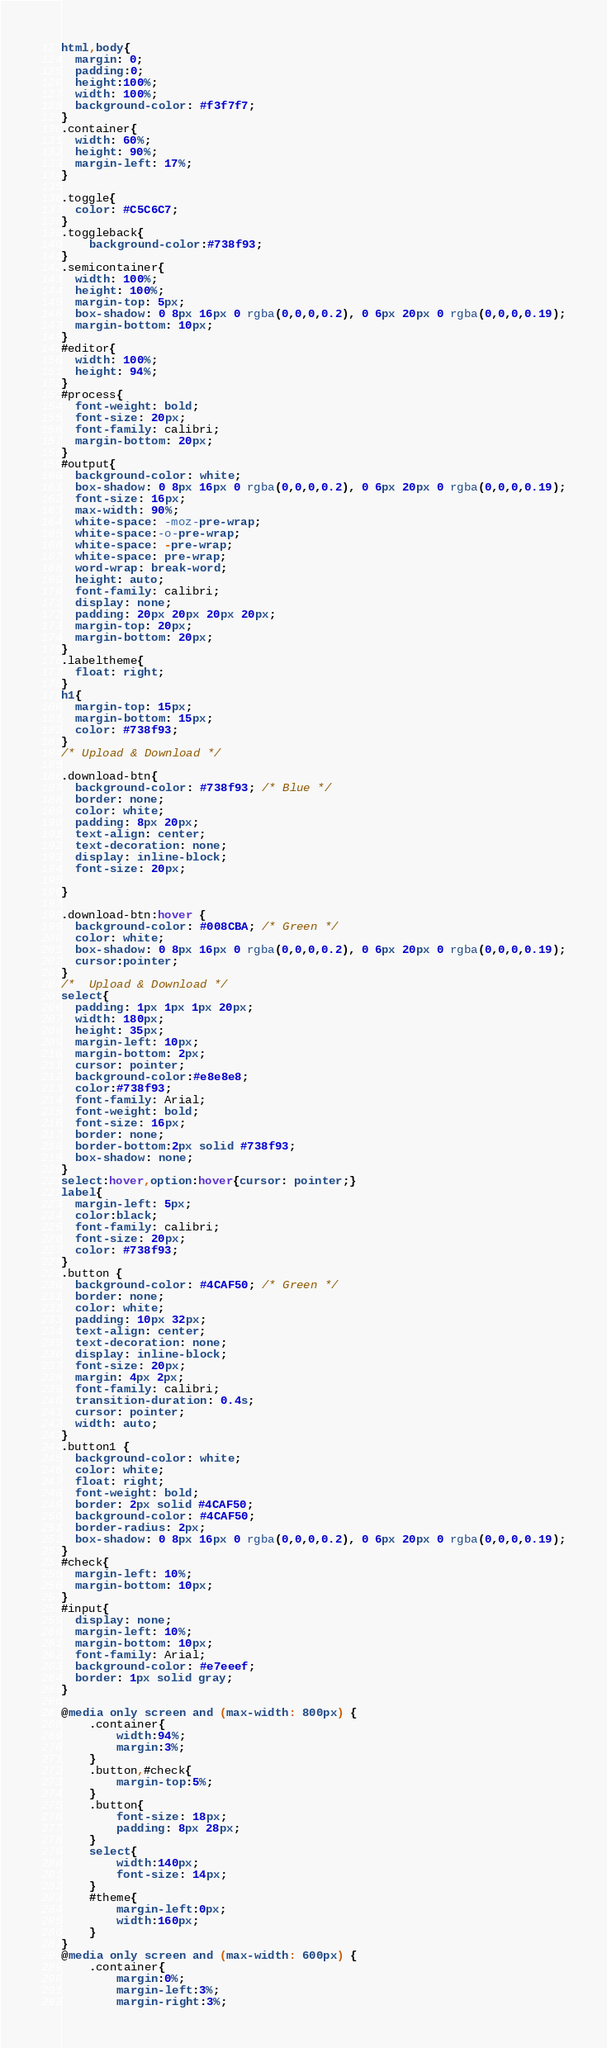<code> <loc_0><loc_0><loc_500><loc_500><_CSS_>html,body{
  margin: 0;
  padding:0;
  height:100%;
  width: 100%;
  background-color: #f3f7f7;
}
.container{
  width: 60%;
  height: 90%;
  margin-left: 17%;
}

.toggle{
  color: #C5C6C7;
}
.toggleback{
	background-color:#738f93;
}	
.semicontainer{
  width: 100%;
  height: 100%;
  margin-top: 5px;
  box-shadow: 0 8px 16px 0 rgba(0,0,0,0.2), 0 6px 20px 0 rgba(0,0,0,0.19);
  margin-bottom: 10px;
}
#editor{
  width: 100%;
  height: 94%;
}
#process{
  font-weight: bold;
  font-size: 20px;
  font-family: calibri;
  margin-bottom: 20px;
}
#output{
  background-color: white;
  box-shadow: 0 8px 16px 0 rgba(0,0,0,0.2), 0 6px 20px 0 rgba(0,0,0,0.19);
  font-size: 16px;
  max-width: 90%;
  white-space: -moz-pre-wrap;
  white-space:-o-pre-wrap;
  white-space: -pre-wrap;
  white-space: pre-wrap;
  word-wrap: break-word;
  height: auto;
  font-family: calibri;
  display: none;
  padding: 20px 20px 20px 20px;
  margin-top: 20px;
  margin-bottom: 20px;
}
.labeltheme{
  float: right;
}
h1{
  margin-top: 15px;
  margin-bottom: 15px;
  color: #738f93;
}
/* Upload & Download */

.download-btn{
  background-color: #738f93; /* Blue */
  border: none;
  color: white;
  padding: 8px 20px;
  text-align: center;
  text-decoration: none;
  display: inline-block;
  font-size: 20px;

}

.download-btn:hover {
  background-color: #008CBA; /* Green */
  color: white;
  box-shadow: 0 8px 16px 0 rgba(0,0,0,0.2), 0 6px 20px 0 rgba(0,0,0,0.19);
  cursor:pointer;
}
/*  Upload & Download */
select{
  padding: 1px 1px 1px 20px;
  width: 180px;
  height: 35px;
  margin-left: 10px;
  margin-bottom: 2px;
  cursor: pointer;
  background-color:#e8e8e8;
  color:#738f93;
  font-family: Arial;
  font-weight: bold;
  font-size: 16px;
  border: none;
  border-bottom:2px solid #738f93;
  box-shadow: none;
}
select:hover,option:hover{cursor: pointer;}
label{
  margin-left: 5px;
  color:black;
  font-family: calibri;
  font-size: 20px;
  color: #738f93;
}
.button {
  background-color: #4CAF50; /* Green */
  border: none;
  color: white;
  padding: 10px 32px;
  text-align: center;
  text-decoration: none;
  display: inline-block;
  font-size: 20px;
  margin: 4px 2px;
  font-family: calibri;
  transition-duration: 0.4s;
  cursor: pointer;
  width: auto;
}
.button1 {
  background-color: white;
  color: white;
  float: right;
  font-weight: bold;
  border: 2px solid #4CAF50;
  background-color: #4CAF50;
  border-radius: 2px;
  box-shadow: 0 8px 16px 0 rgba(0,0,0,0.2), 0 6px 20px 0 rgba(0,0,0,0.19);
}
#check{
  margin-left: 10%;
  margin-bottom: 10px;
}
#input{
  display: none;
  margin-left: 10%;
  margin-bottom: 10px;
  font-family: Arial;
  background-color: #e7eeef;
  border: 1px solid gray;
}

@media only screen and (max-width: 800px) {
	.container{
		width:94%;
		margin:3%;
	}
	.button,#check{
		margin-top:5%;
	}
	.button{
		font-size: 18px;
		padding: 8px 28px;
	}
	select{
		width:140px;
		font-size: 14px;
	}
	#theme{
		margin-left:0px;
		width:160px;
	}
}
@media only screen and (max-width: 600px) {
	.container{
		margin:0%;
		margin-left:3%;
		margin-right:3%;</code> 